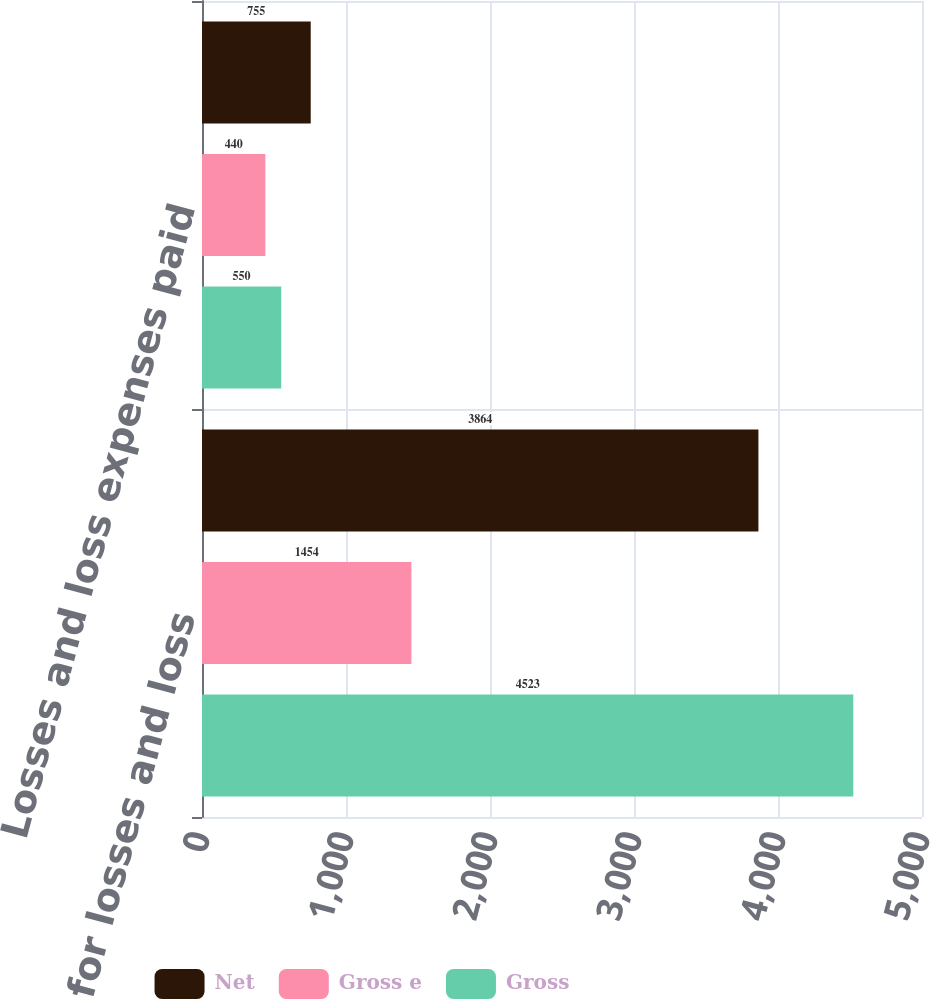<chart> <loc_0><loc_0><loc_500><loc_500><stacked_bar_chart><ecel><fcel>Reserve for losses and loss<fcel>Losses and loss expenses paid<nl><fcel>Net<fcel>3864<fcel>755<nl><fcel>Gross e<fcel>1454<fcel>440<nl><fcel>Gross<fcel>4523<fcel>550<nl></chart> 